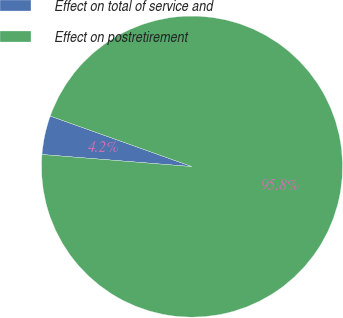Convert chart to OTSL. <chart><loc_0><loc_0><loc_500><loc_500><pie_chart><fcel>Effect on total of service and<fcel>Effect on postretirement<nl><fcel>4.17%<fcel>95.83%<nl></chart> 